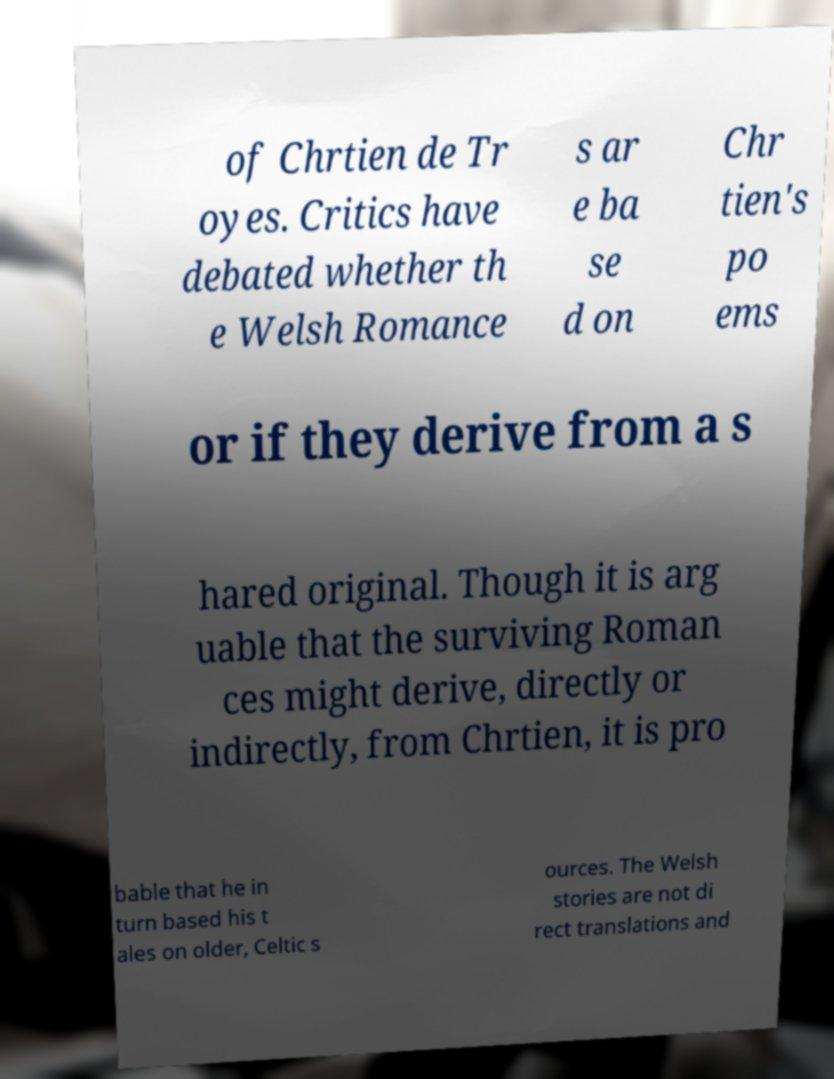There's text embedded in this image that I need extracted. Can you transcribe it verbatim? of Chrtien de Tr oyes. Critics have debated whether th e Welsh Romance s ar e ba se d on Chr tien's po ems or if they derive from a s hared original. Though it is arg uable that the surviving Roman ces might derive, directly or indirectly, from Chrtien, it is pro bable that he in turn based his t ales on older, Celtic s ources. The Welsh stories are not di rect translations and 